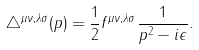<formula> <loc_0><loc_0><loc_500><loc_500>\triangle ^ { \mu \nu , \lambda \sigma } ( p ) = \frac { 1 } { 2 } f ^ { \mu \nu , \lambda \sigma } \frac { 1 } { p ^ { 2 } - i \epsilon } .</formula> 